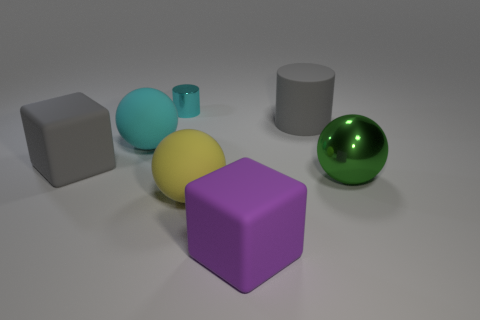Add 3 purple rubber cubes. How many objects exist? 10 Subtract all gray blocks. Subtract all red cylinders. How many blocks are left? 1 Subtract all spheres. How many objects are left? 4 Subtract 0 brown cylinders. How many objects are left? 7 Subtract all big cyan balls. Subtract all large matte cubes. How many objects are left? 4 Add 7 purple things. How many purple things are left? 8 Add 7 red cylinders. How many red cylinders exist? 7 